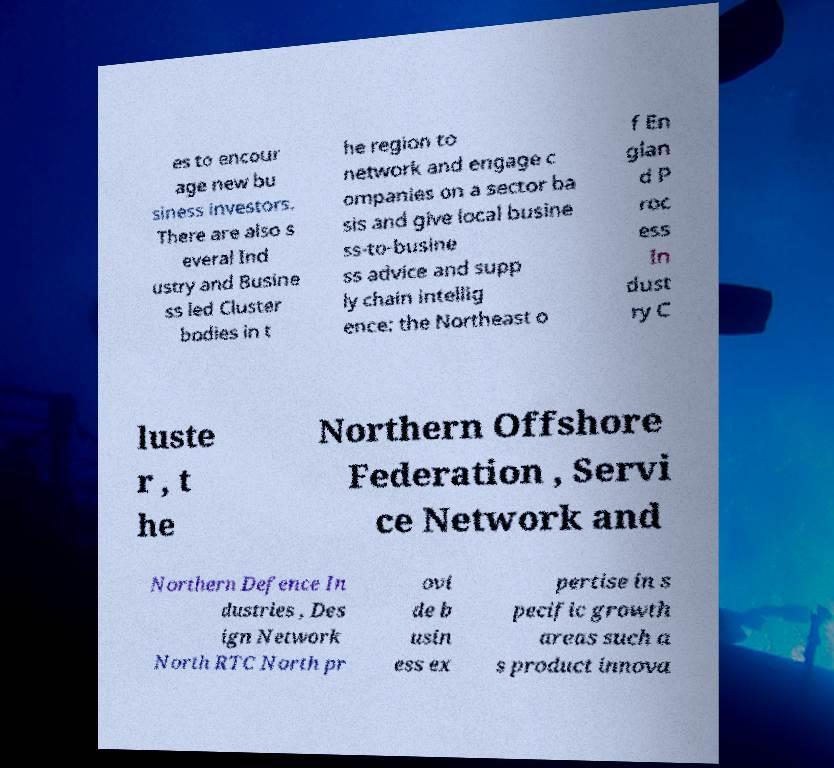Could you assist in decoding the text presented in this image and type it out clearly? es to encour age new bu siness investors. There are also s everal Ind ustry and Busine ss led Cluster bodies in t he region to network and engage c ompanies on a sector ba sis and give local busine ss-to-busine ss advice and supp ly chain intellig ence: the Northeast o f En glan d P roc ess In dust ry C luste r , t he Northern Offshore Federation , Servi ce Network and Northern Defence In dustries , Des ign Network North RTC North pr ovi de b usin ess ex pertise in s pecific growth areas such a s product innova 